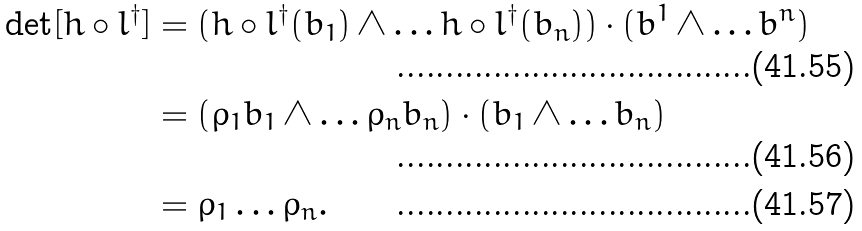Convert formula to latex. <formula><loc_0><loc_0><loc_500><loc_500>\det [ h \circ l ^ { \dagger } ] & = ( h \circ l ^ { \dagger } ( b _ { 1 } ) \wedge \dots h \circ l ^ { \dagger } ( b _ { n } ) ) \cdot ( b ^ { 1 } \wedge \dots b ^ { n } ) \\ & = ( \rho _ { 1 } b _ { 1 } \wedge \dots \rho _ { n } b _ { n } ) \cdot ( b _ { 1 } \wedge \dots b _ { n } ) \\ & = \rho _ { 1 } \dots \rho _ { n } .</formula> 